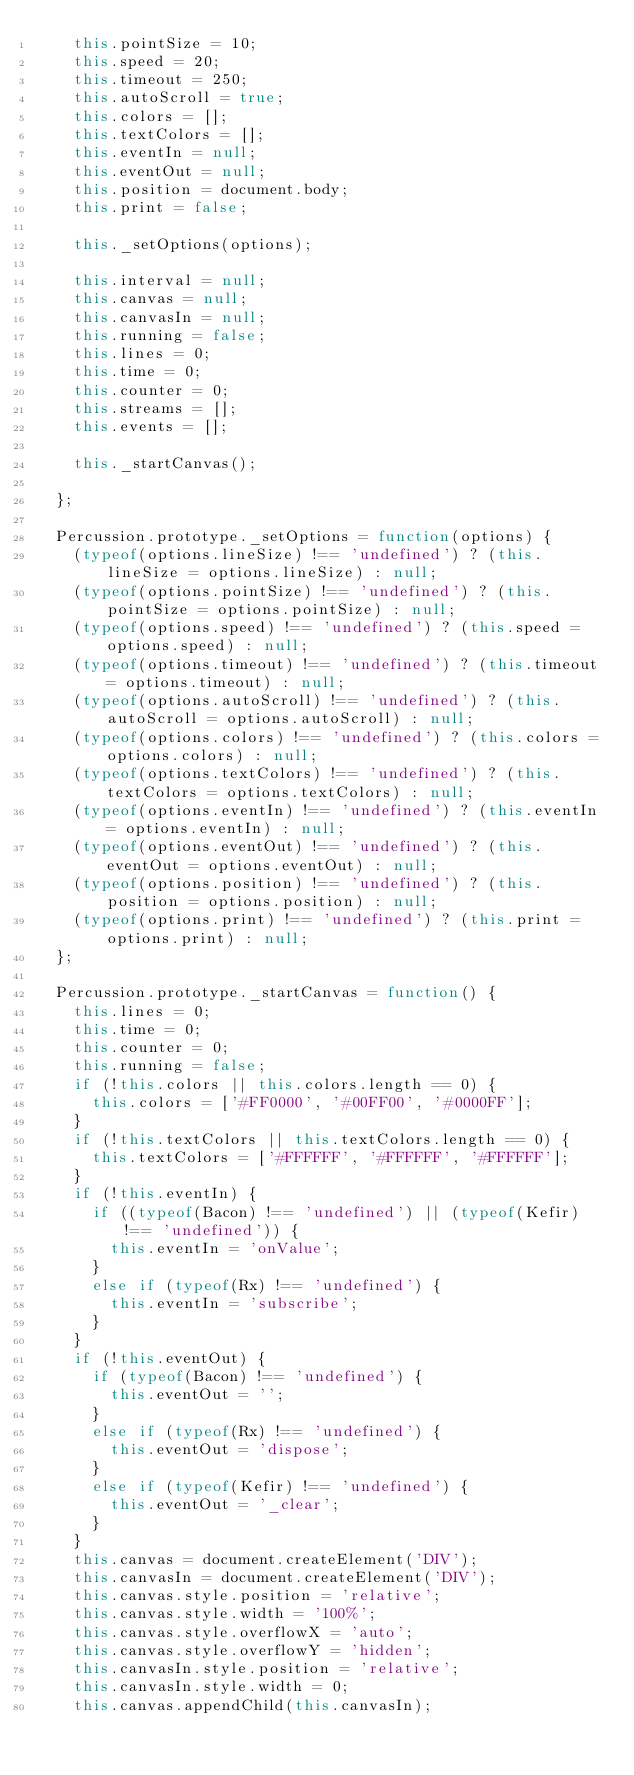Convert code to text. <code><loc_0><loc_0><loc_500><loc_500><_JavaScript_>    this.pointSize = 10;
    this.speed = 20;
    this.timeout = 250;
    this.autoScroll = true;
    this.colors = [];
    this.textColors = [];
    this.eventIn = null;
    this.eventOut = null;
    this.position = document.body;
    this.print = false;

    this._setOptions(options);

    this.interval = null;
    this.canvas = null;
    this.canvasIn = null;
    this.running = false;
    this.lines = 0;
    this.time = 0;
    this.counter = 0;
    this.streams = [];
    this.events = [];

    this._startCanvas();

  };

  Percussion.prototype._setOptions = function(options) {
    (typeof(options.lineSize) !== 'undefined') ? (this.lineSize = options.lineSize) : null;
    (typeof(options.pointSize) !== 'undefined') ? (this.pointSize = options.pointSize) : null;
    (typeof(options.speed) !== 'undefined') ? (this.speed = options.speed) : null;
    (typeof(options.timeout) !== 'undefined') ? (this.timeout = options.timeout) : null;
    (typeof(options.autoScroll) !== 'undefined') ? (this.autoScroll = options.autoScroll) : null;
    (typeof(options.colors) !== 'undefined') ? (this.colors = options.colors) : null;
    (typeof(options.textColors) !== 'undefined') ? (this.textColors = options.textColors) : null;
    (typeof(options.eventIn) !== 'undefined') ? (this.eventIn = options.eventIn) : null;
    (typeof(options.eventOut) !== 'undefined') ? (this.eventOut = options.eventOut) : null;
    (typeof(options.position) !== 'undefined') ? (this.position = options.position) : null;
    (typeof(options.print) !== 'undefined') ? (this.print = options.print) : null;
  };

  Percussion.prototype._startCanvas = function() {
    this.lines = 0;
    this.time = 0;
    this.counter = 0;
    this.running = false;
    if (!this.colors || this.colors.length == 0) {
      this.colors = ['#FF0000', '#00FF00', '#0000FF'];
    }
    if (!this.textColors || this.textColors.length == 0) {
      this.textColors = ['#FFFFFF', '#FFFFFF', '#FFFFFF'];
    }
    if (!this.eventIn) {
      if ((typeof(Bacon) !== 'undefined') || (typeof(Kefir) !== 'undefined')) {
        this.eventIn = 'onValue';
      }
      else if (typeof(Rx) !== 'undefined') {
        this.eventIn = 'subscribe';
      }
    }
    if (!this.eventOut) {
      if (typeof(Bacon) !== 'undefined') {
        this.eventOut = '';
      }
      else if (typeof(Rx) !== 'undefined') {
        this.eventOut = 'dispose';
      }
      else if (typeof(Kefir) !== 'undefined') {
        this.eventOut = '_clear';
      }
    }
    this.canvas = document.createElement('DIV');
    this.canvasIn = document.createElement('DIV');
    this.canvas.style.position = 'relative';
    this.canvas.style.width = '100%';
    this.canvas.style.overflowX = 'auto';
    this.canvas.style.overflowY = 'hidden';
    this.canvasIn.style.position = 'relative';
    this.canvasIn.style.width = 0;
    this.canvas.appendChild(this.canvasIn);</code> 